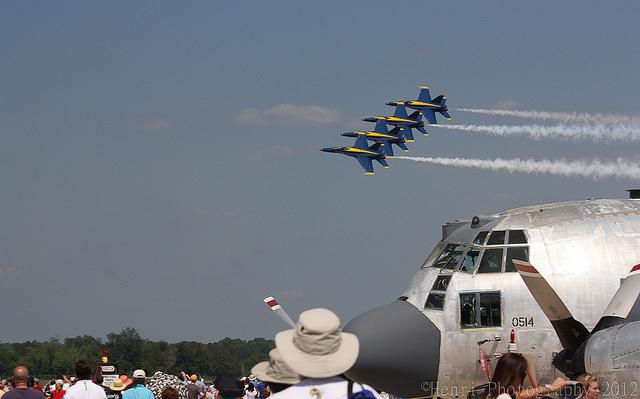How many trails of smoke are there?
Quick response, please. 3. How many people are wearing a hat?
Be succinct. 2. What is in the air?
Keep it brief. Planes. 